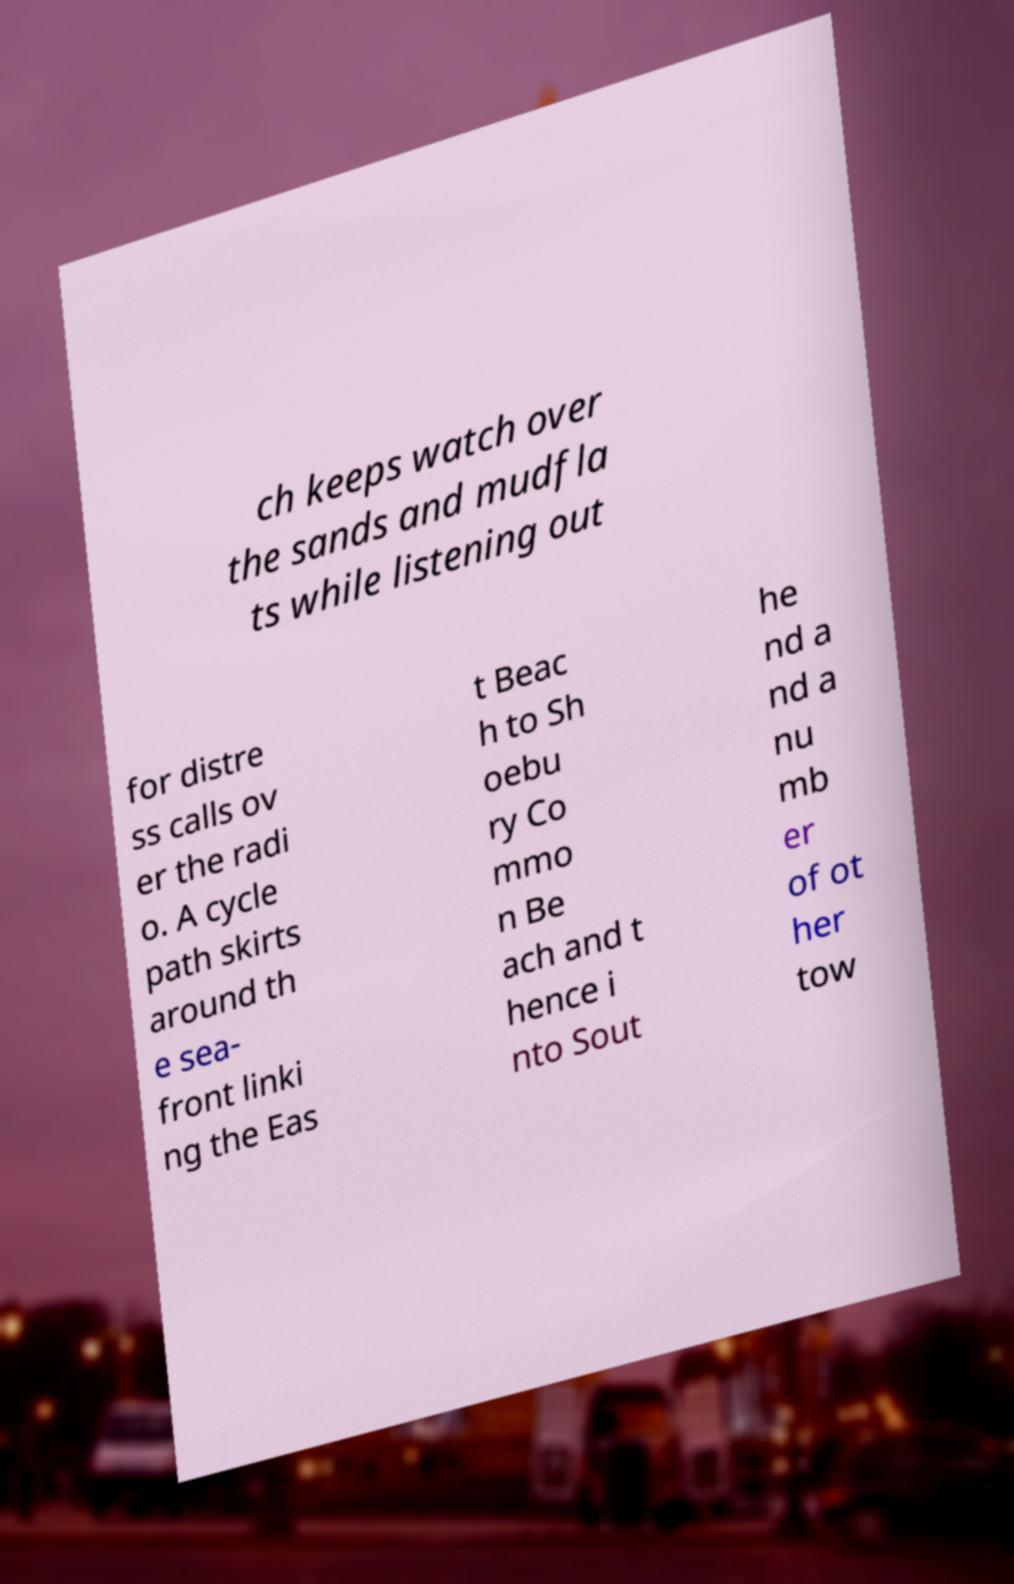Could you extract and type out the text from this image? ch keeps watch over the sands and mudfla ts while listening out for distre ss calls ov er the radi o. A cycle path skirts around th e sea- front linki ng the Eas t Beac h to Sh oebu ry Co mmo n Be ach and t hence i nto Sout he nd a nd a nu mb er of ot her tow 